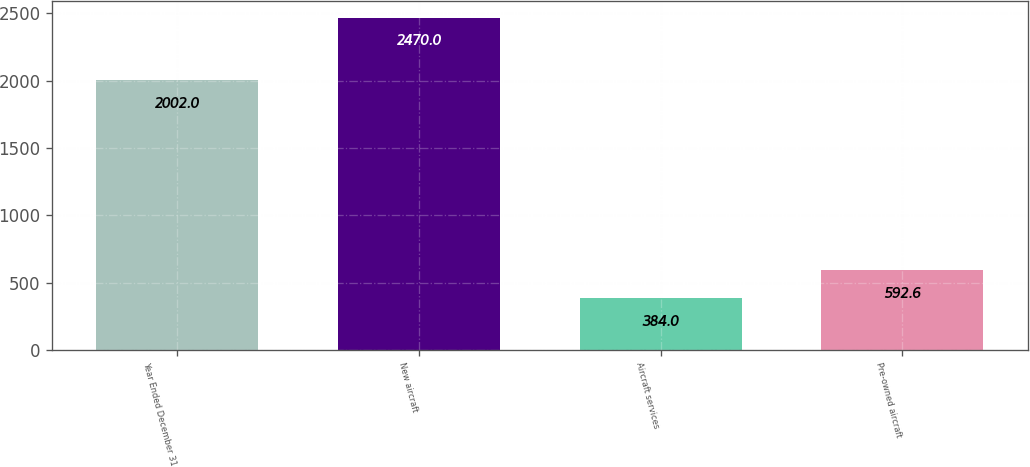Convert chart. <chart><loc_0><loc_0><loc_500><loc_500><bar_chart><fcel>Year Ended December 31<fcel>New aircraft<fcel>Aircraft services<fcel>Pre-owned aircraft<nl><fcel>2002<fcel>2470<fcel>384<fcel>592.6<nl></chart> 